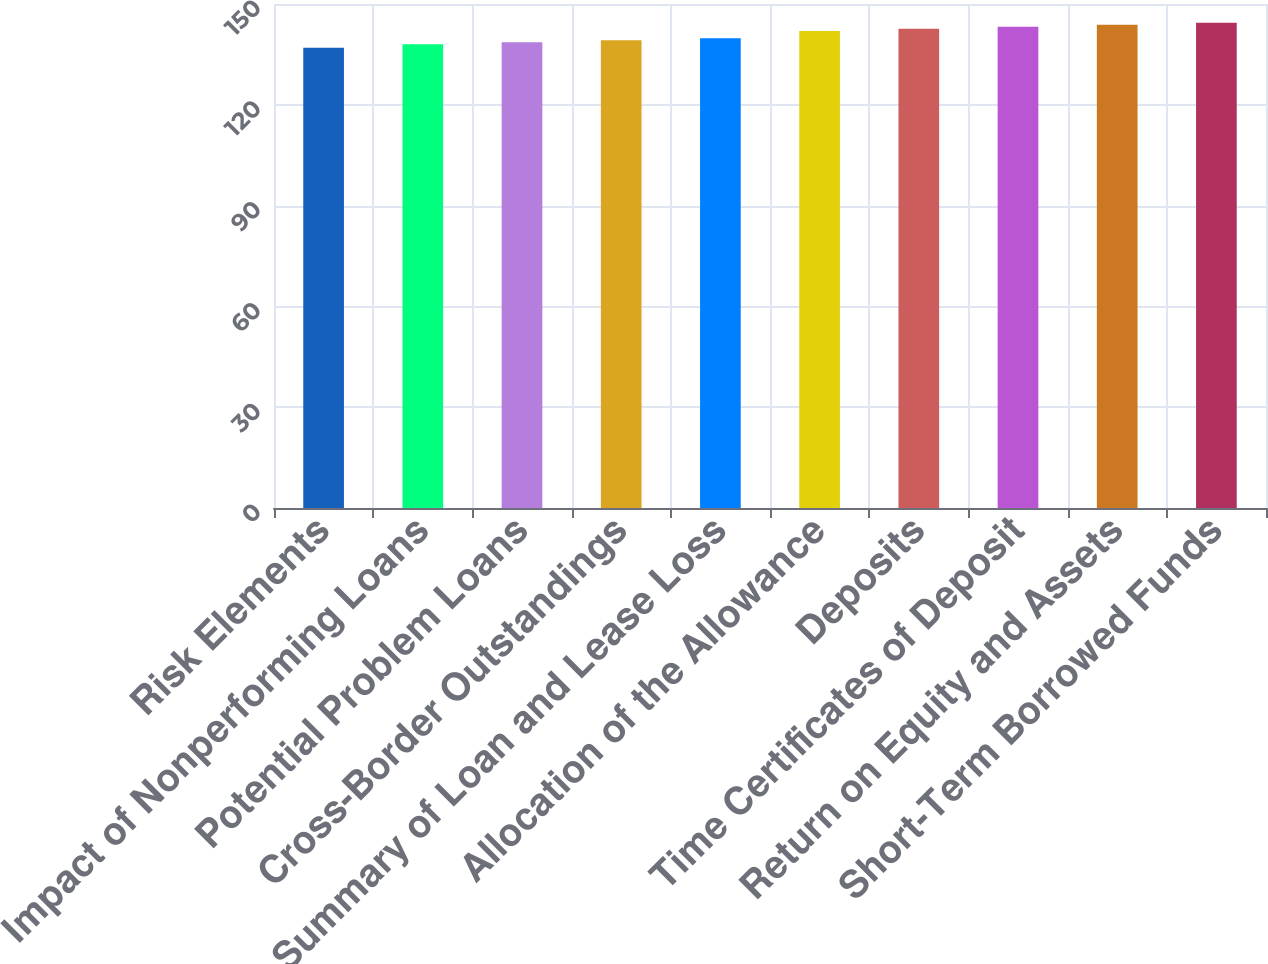Convert chart. <chart><loc_0><loc_0><loc_500><loc_500><bar_chart><fcel>Risk Elements<fcel>Impact of Nonperforming Loans<fcel>Potential Problem Loans<fcel>Cross-Border Outstandings<fcel>Summary of Loan and Lease Loss<fcel>Allocation of the Allowance<fcel>Deposits<fcel>Time Certificates of Deposit<fcel>Return on Equity and Assets<fcel>Short-Term Borrowed Funds<nl><fcel>137<fcel>138<fcel>138.6<fcel>139.2<fcel>139.8<fcel>142<fcel>142.6<fcel>143.2<fcel>143.8<fcel>144.4<nl></chart> 